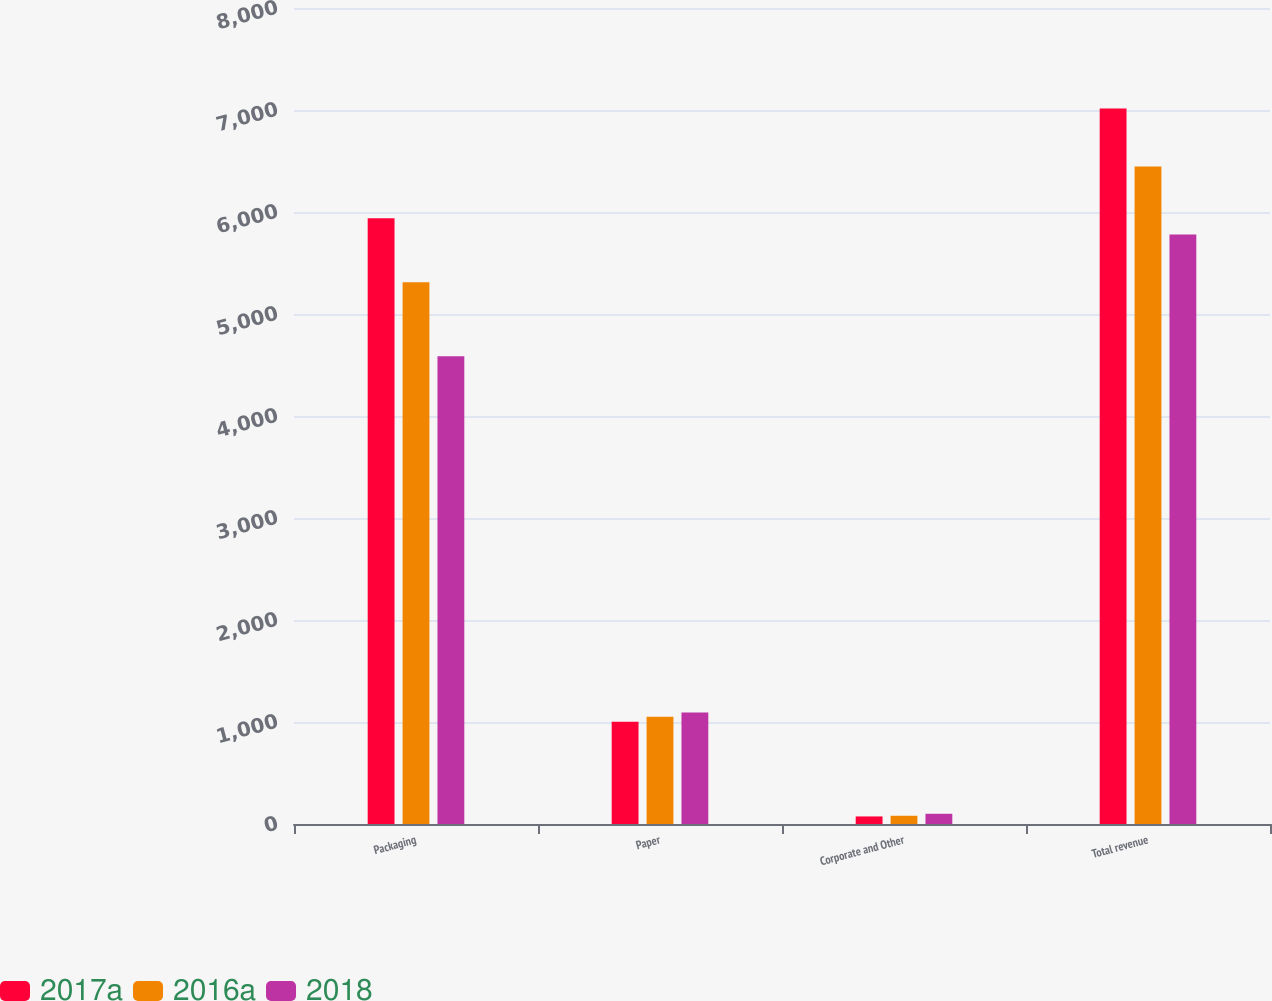Convert chart to OTSL. <chart><loc_0><loc_0><loc_500><loc_500><stacked_bar_chart><ecel><fcel>Packaging<fcel>Paper<fcel>Corporate and Other<fcel>Total revenue<nl><fcel>2017a<fcel>5938.5<fcel>1002<fcel>74.1<fcel>7014.6<nl><fcel>2016a<fcel>5312.3<fcel>1051.8<fcel>80.8<fcel>6444.9<nl><fcel>2018<fcel>4584.8<fcel>1093.9<fcel>100.3<fcel>5779<nl></chart> 